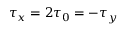<formula> <loc_0><loc_0><loc_500><loc_500>\tau _ { x } = 2 \tau _ { 0 } = - \tau _ { y }</formula> 